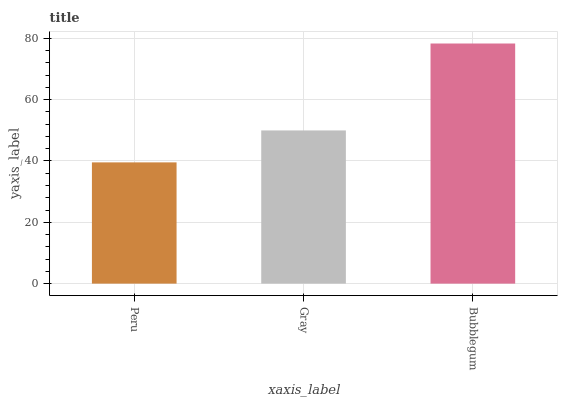Is Peru the minimum?
Answer yes or no. Yes. Is Bubblegum the maximum?
Answer yes or no. Yes. Is Gray the minimum?
Answer yes or no. No. Is Gray the maximum?
Answer yes or no. No. Is Gray greater than Peru?
Answer yes or no. Yes. Is Peru less than Gray?
Answer yes or no. Yes. Is Peru greater than Gray?
Answer yes or no. No. Is Gray less than Peru?
Answer yes or no. No. Is Gray the high median?
Answer yes or no. Yes. Is Gray the low median?
Answer yes or no. Yes. Is Bubblegum the high median?
Answer yes or no. No. Is Peru the low median?
Answer yes or no. No. 